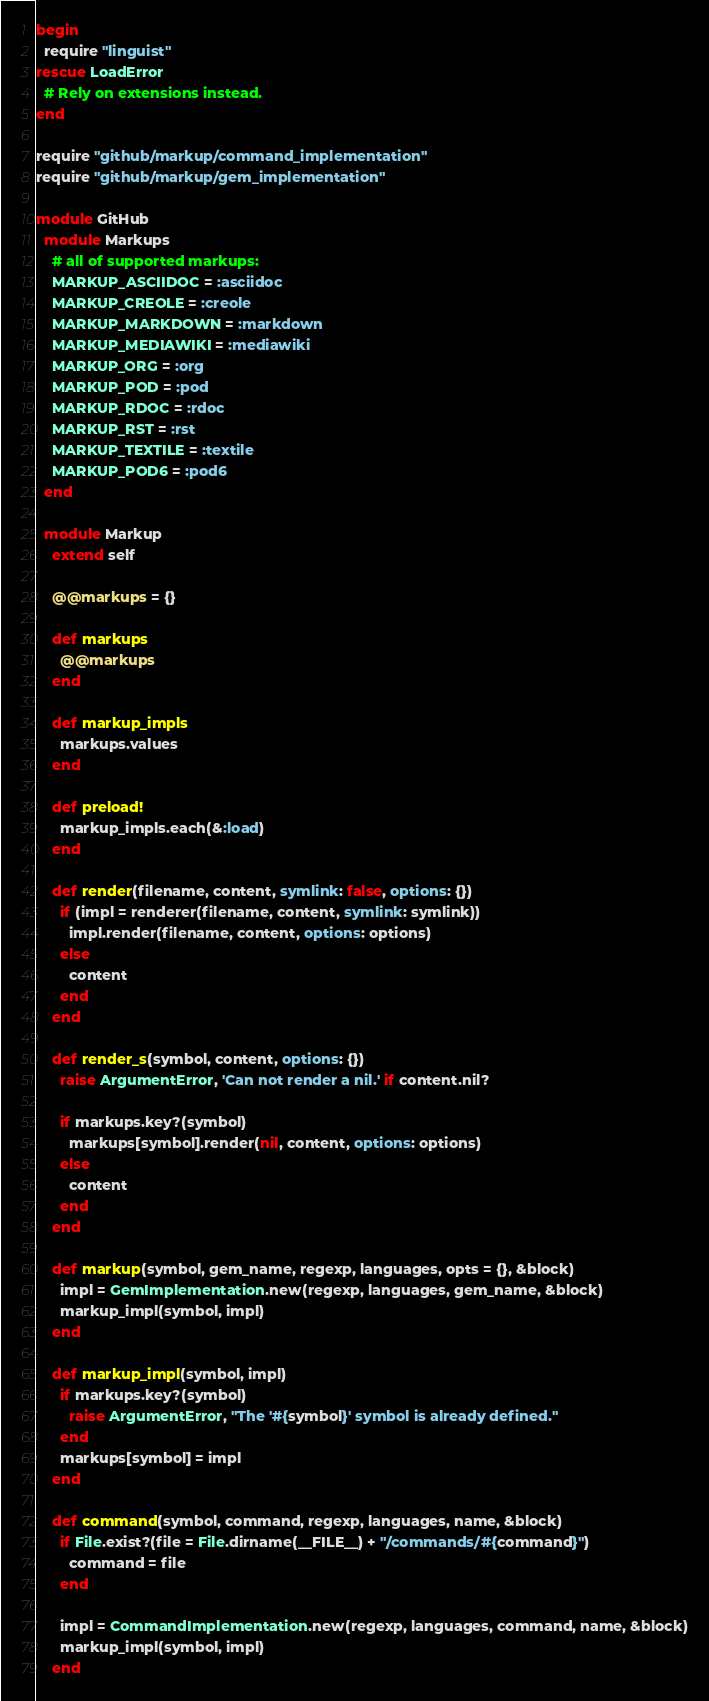Convert code to text. <code><loc_0><loc_0><loc_500><loc_500><_Ruby_>begin
  require "linguist"
rescue LoadError
  # Rely on extensions instead.
end

require "github/markup/command_implementation"
require "github/markup/gem_implementation"

module GitHub
  module Markups
    # all of supported markups:
    MARKUP_ASCIIDOC = :asciidoc
    MARKUP_CREOLE = :creole
    MARKUP_MARKDOWN = :markdown
    MARKUP_MEDIAWIKI = :mediawiki
    MARKUP_ORG = :org
    MARKUP_POD = :pod
    MARKUP_RDOC = :rdoc
    MARKUP_RST = :rst
    MARKUP_TEXTILE = :textile
    MARKUP_POD6 = :pod6
  end

  module Markup
    extend self

    @@markups = {}

    def markups
      @@markups
    end

    def markup_impls
      markups.values
    end

    def preload!
      markup_impls.each(&:load)
    end

    def render(filename, content, symlink: false, options: {})
      if (impl = renderer(filename, content, symlink: symlink))
        impl.render(filename, content, options: options)
      else
        content
      end
    end

    def render_s(symbol, content, options: {})
      raise ArgumentError, 'Can not render a nil.' if content.nil?

      if markups.key?(symbol)
        markups[symbol].render(nil, content, options: options)
      else
        content
      end
    end

    def markup(symbol, gem_name, regexp, languages, opts = {}, &block)
      impl = GemImplementation.new(regexp, languages, gem_name, &block)
      markup_impl(symbol, impl)
    end

    def markup_impl(symbol, impl)
      if markups.key?(symbol)
        raise ArgumentError, "The '#{symbol}' symbol is already defined."
      end
      markups[symbol] = impl
    end

    def command(symbol, command, regexp, languages, name, &block)
      if File.exist?(file = File.dirname(__FILE__) + "/commands/#{command}")
        command = file
      end

      impl = CommandImplementation.new(regexp, languages, command, name, &block)
      markup_impl(symbol, impl)
    end
</code> 